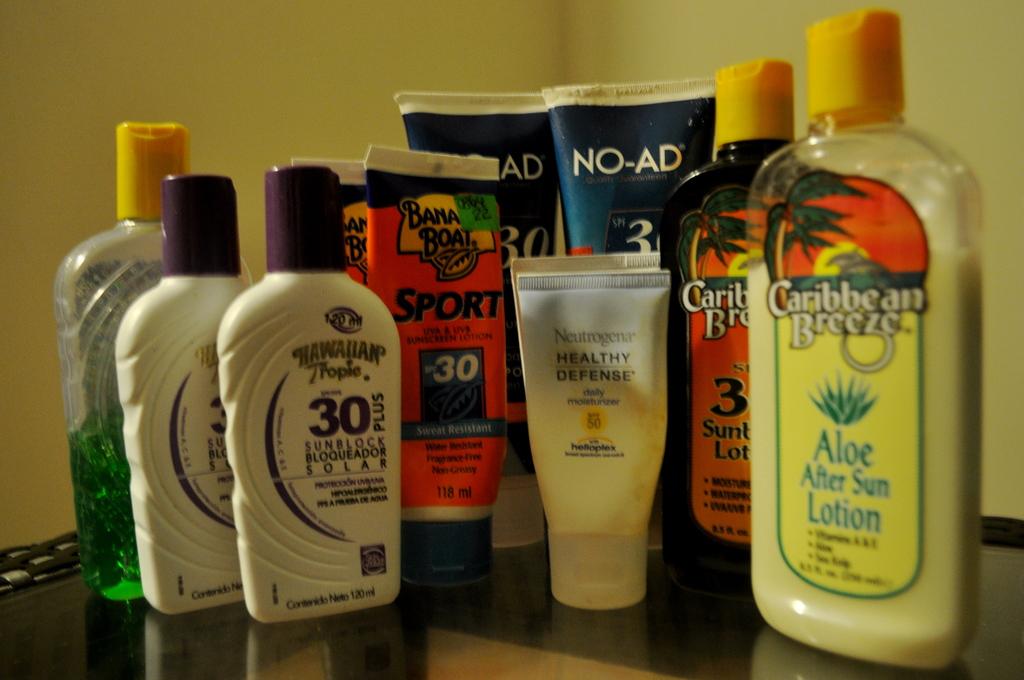What brand is the aloe vera cream?
Offer a very short reply. Caribbean breeze. What spf is the sunscreen?
Make the answer very short. 30. 